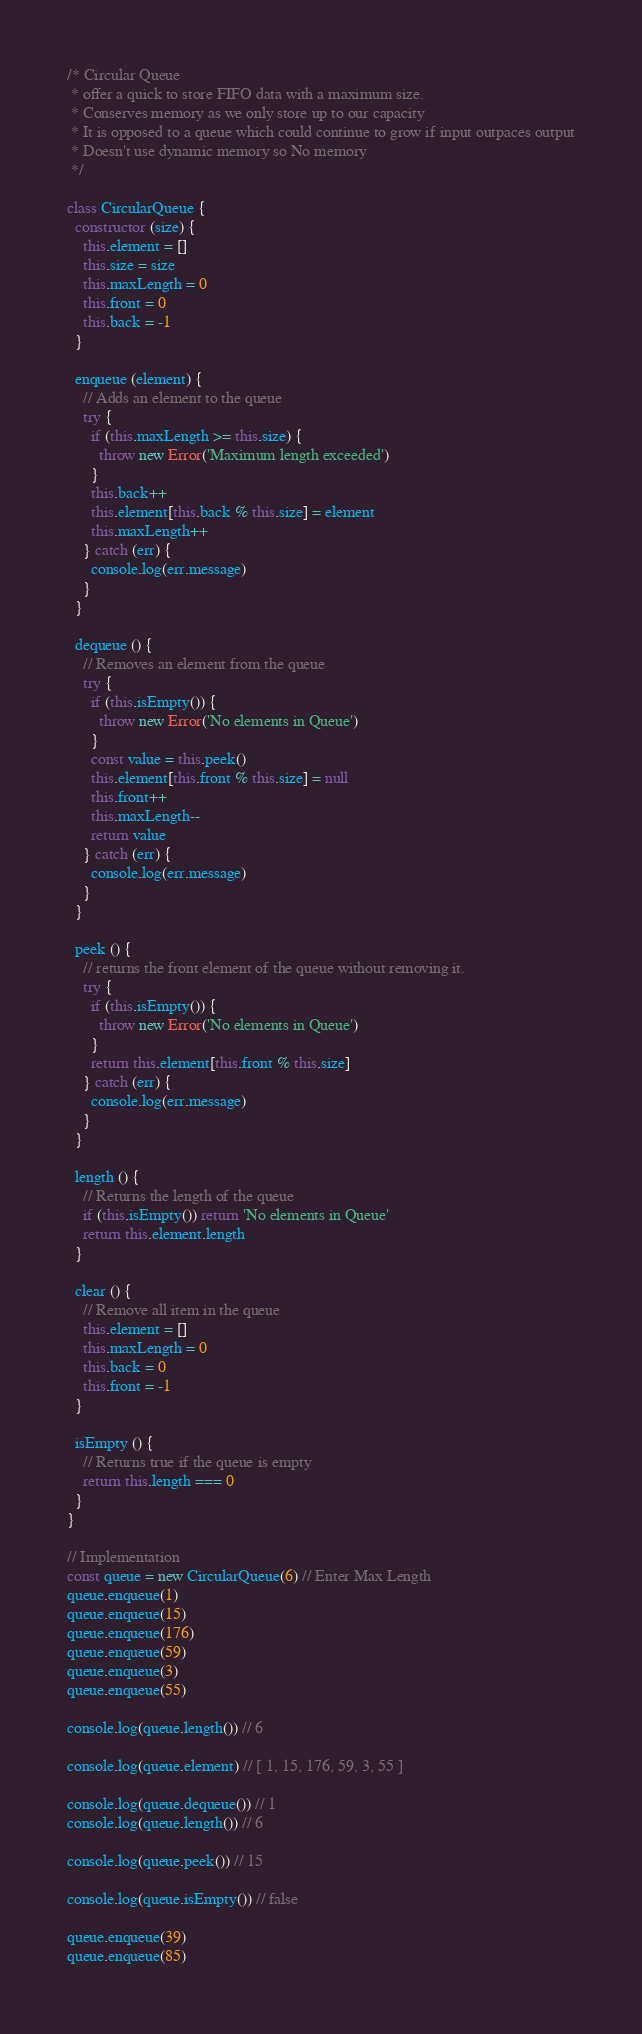<code> <loc_0><loc_0><loc_500><loc_500><_JavaScript_>/* Circular Queue
 * offer a quick to store FIFO data with a maximum size.
 * Conserves memory as we only store up to our capacity
 * It is opposed to a queue which could continue to grow if input outpaces output
 * Doesn't use dynamic memory so No memory
 */

class CircularQueue {
  constructor (size) {
    this.element = []
    this.size = size
    this.maxLength = 0
    this.front = 0
    this.back = -1
  }

  enqueue (element) {
    // Adds an element to the queue
    try {
      if (this.maxLength >= this.size) {
        throw new Error('Maximum length exceeded')
      }
      this.back++
      this.element[this.back % this.size] = element
      this.maxLength++
    } catch (err) {
      console.log(err.message)
    }
  }

  dequeue () {
    // Removes an element from the queue
    try {
      if (this.isEmpty()) {
        throw new Error('No elements in Queue')
      }
      const value = this.peek()
      this.element[this.front % this.size] = null
      this.front++
      this.maxLength--
      return value
    } catch (err) {
      console.log(err.message)
    }
  }

  peek () {
    // returns the front element of the queue without removing it.
    try {
      if (this.isEmpty()) {
        throw new Error('No elements in Queue')
      }
      return this.element[this.front % this.size]
    } catch (err) {
      console.log(err.message)
    }
  }

  length () {
    // Returns the length of the queue
    if (this.isEmpty()) return 'No elements in Queue'
    return this.element.length
  }

  clear () {
    // Remove all item in the queue
    this.element = []
    this.maxLength = 0
    this.back = 0
    this.front = -1
  }

  isEmpty () {
    // Returns true if the queue is empty
    return this.length === 0
  }
}

// Implementation
const queue = new CircularQueue(6) // Enter Max Length
queue.enqueue(1)
queue.enqueue(15)
queue.enqueue(176)
queue.enqueue(59)
queue.enqueue(3)
queue.enqueue(55)

console.log(queue.length()) // 6

console.log(queue.element) // [ 1, 15, 176, 59, 3, 55 ]

console.log(queue.dequeue()) // 1
console.log(queue.length()) // 6

console.log(queue.peek()) // 15

console.log(queue.isEmpty()) // false

queue.enqueue(39)
queue.enqueue(85)
</code> 